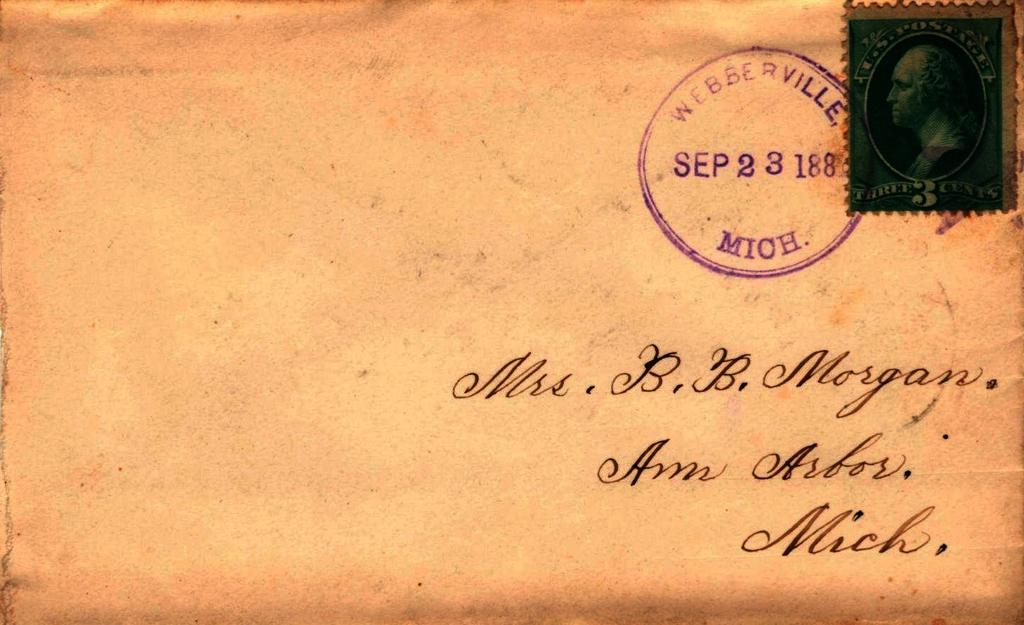Provide a one-sentence caption for the provided image. An envelope is addressed to Mrs. B.B. Morgan. 